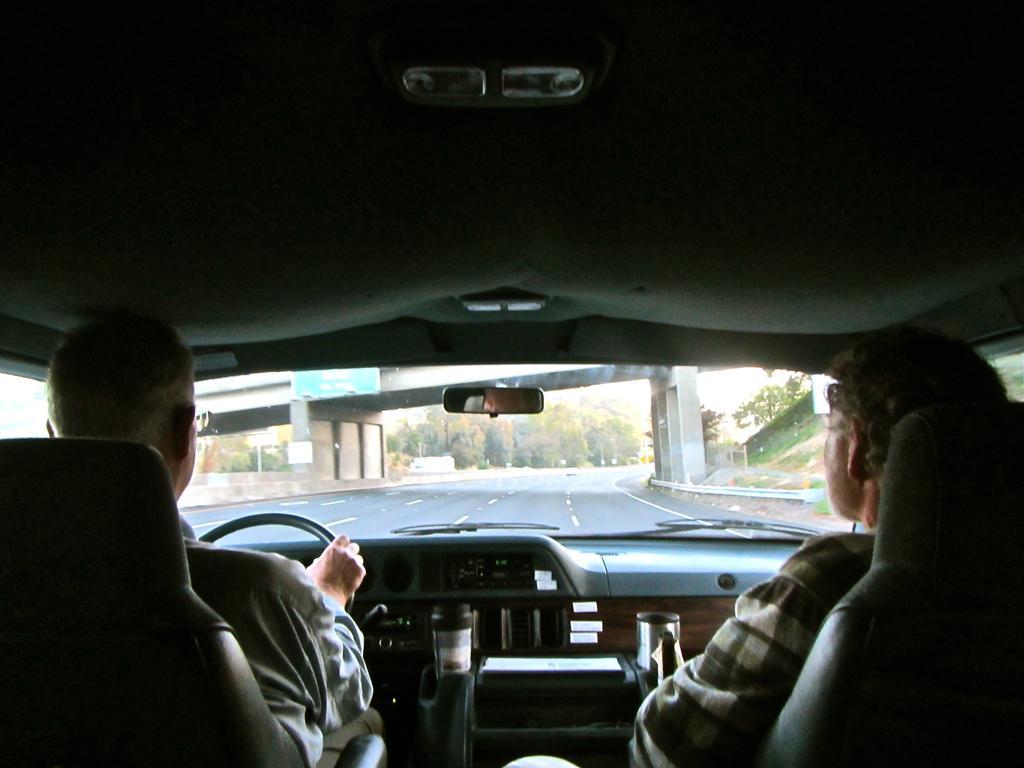Please provide a concise description of this image. In this image there are two persons sitting inside the vehicle , a person holding a steering , and at the background there is road, plants, grass, board attached to the bridge , trees,sky. 